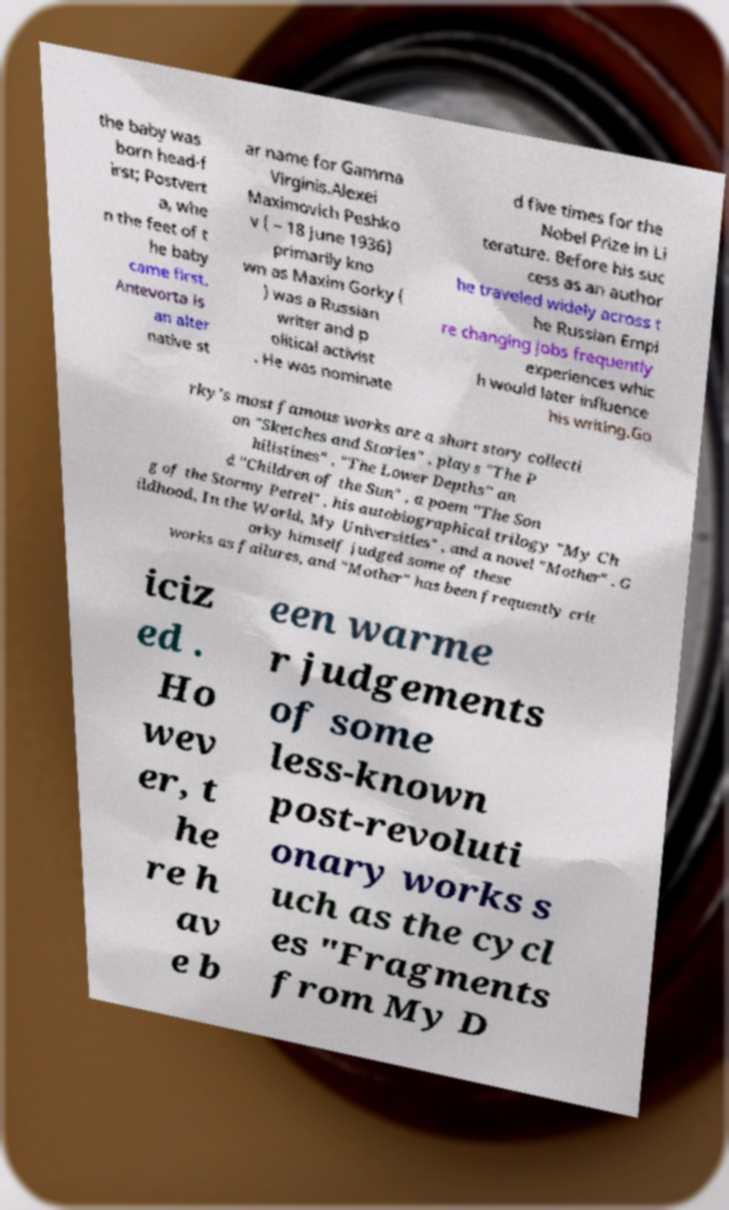Can you accurately transcribe the text from the provided image for me? the baby was born head-f irst; Postvert a, whe n the feet of t he baby came first. Antevorta is an alter native st ar name for Gamma Virginis.Alexei Maximovich Peshko v ( – 18 June 1936) primarily kno wn as Maxim Gorky ( ) was a Russian writer and p olitical activist . He was nominate d five times for the Nobel Prize in Li terature. Before his suc cess as an author he traveled widely across t he Russian Empi re changing jobs frequently experiences whic h would later influence his writing.Go rky's most famous works are a short story collecti on "Sketches and Stories" , plays "The P hilistines" , "The Lower Depths" an d "Children of the Sun" , a poem "The Son g of the Stormy Petrel" , his autobiographical trilogy "My Ch ildhood, In the World, My Universities" , and a novel "Mother" . G orky himself judged some of these works as failures, and "Mother" has been frequently crit iciz ed . Ho wev er, t he re h av e b een warme r judgements of some less-known post-revoluti onary works s uch as the cycl es "Fragments from My D 